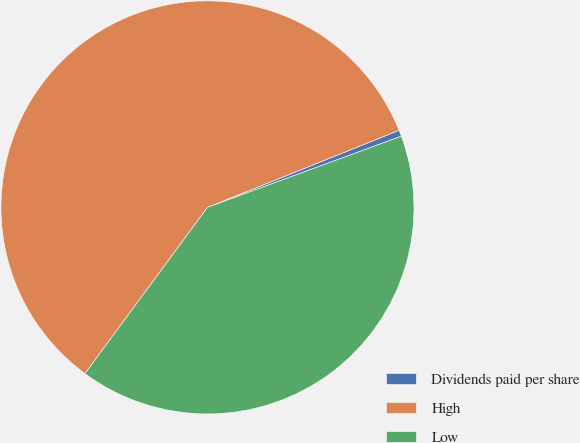<chart> <loc_0><loc_0><loc_500><loc_500><pie_chart><fcel>Dividends paid per share<fcel>High<fcel>Low<nl><fcel>0.49%<fcel>58.8%<fcel>40.71%<nl></chart> 